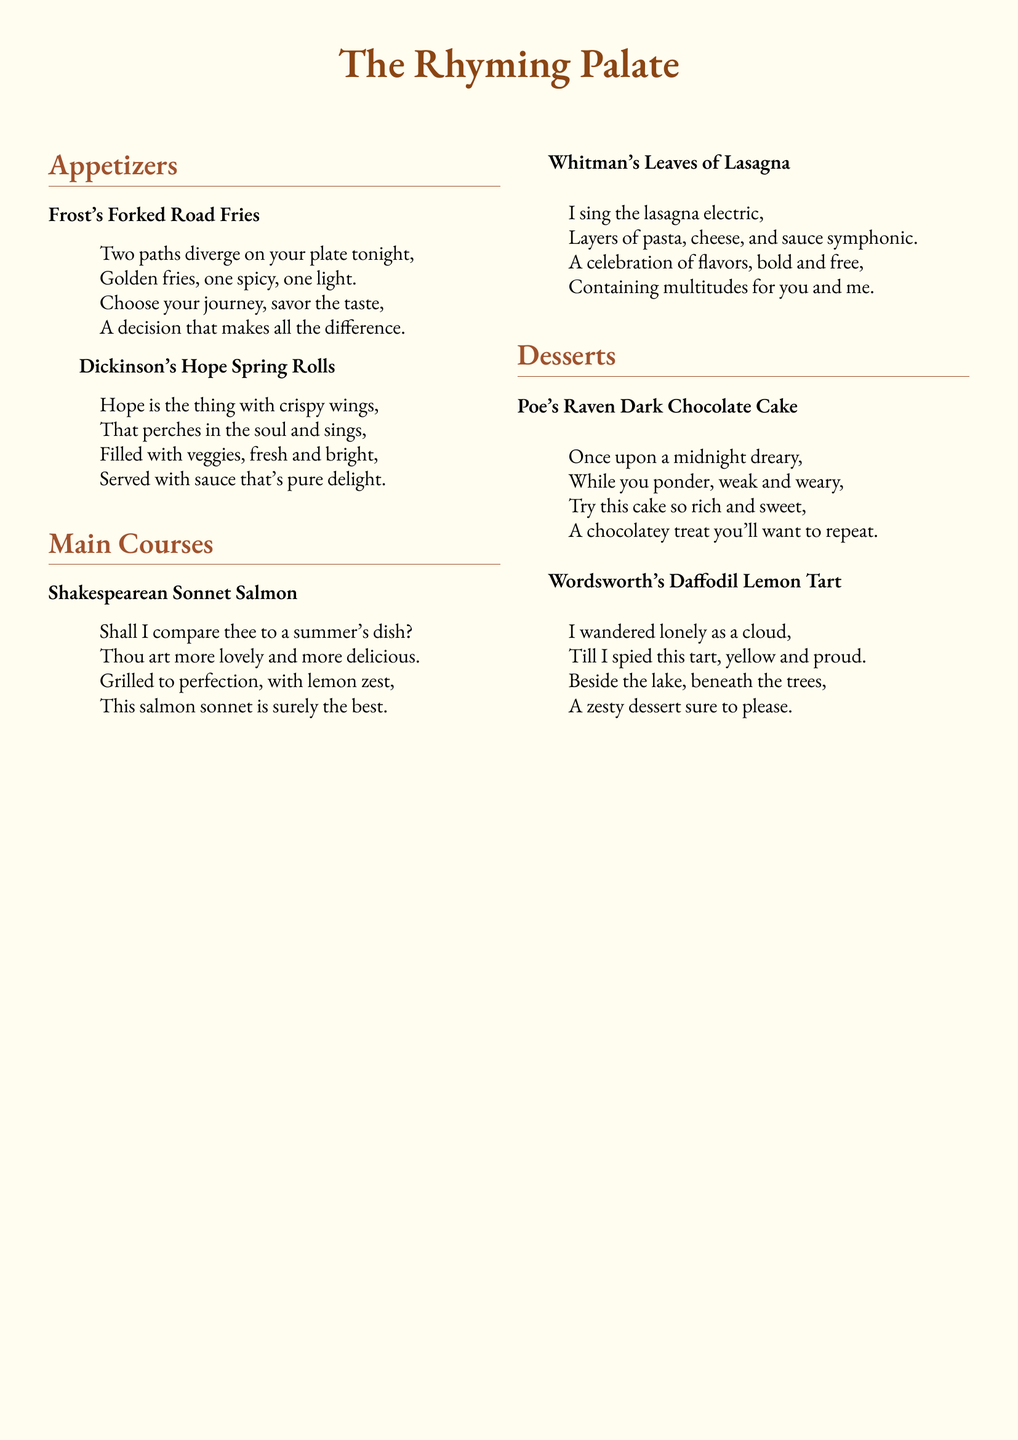What is the name of the restaurant? The name of the restaurant is featured prominently at the top of the document.
Answer: The Rhyming Palate How many appetizers are listed on the menu? The menu features two sections, appetizers and main courses, with a count of items in appetizers.
Answer: 2 What poetic device is used in the dish "Dickinson's Hope Spring Rolls"? The description of the dish uses metaphor, linking the food to hope.
Answer: Metaphor Which poet inspired the "Raven Dark Chocolate Cake"? The dessert is inspired by Edgar Allan Poe, a famous American poet known for his macabre themes.
Answer: Poe What theme does "Frost's Forked Road Fries" evoke? The dish relates to choices and decisions, paralleling the poem's theme of divergent paths in life.
Answer: Choices What is the main ingredient in "Whitman's Leaves of Lasagna"? The main ingredients highlighted in the dish description relate to pasta, cheese, and sauce.
Answer: Lasagna Which dessert features a lemon flavor? The dessert that features lemon is mentioned in its name and description, emphasizing zest and brightness.
Answer: Wordsworth's Daffodil Lemon Tart Is the "Shakespearean Sonnet Salmon" grilled or fried? The menu description clearly states that the salmon is grilled to perfection.
Answer: Grilled 